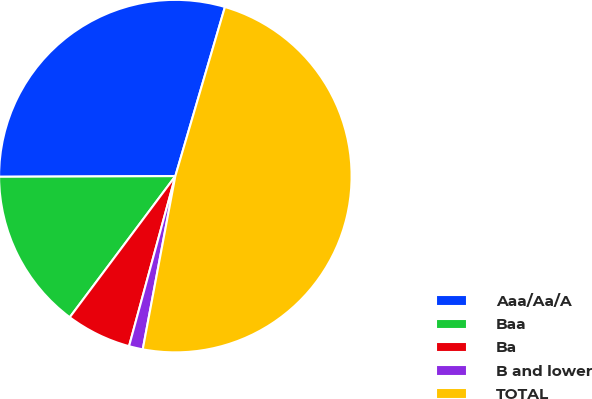Convert chart. <chart><loc_0><loc_0><loc_500><loc_500><pie_chart><fcel>Aaa/Aa/A<fcel>Baa<fcel>Ba<fcel>B and lower<fcel>TOTAL<nl><fcel>29.6%<fcel>14.72%<fcel>5.99%<fcel>1.27%<fcel>48.42%<nl></chart> 